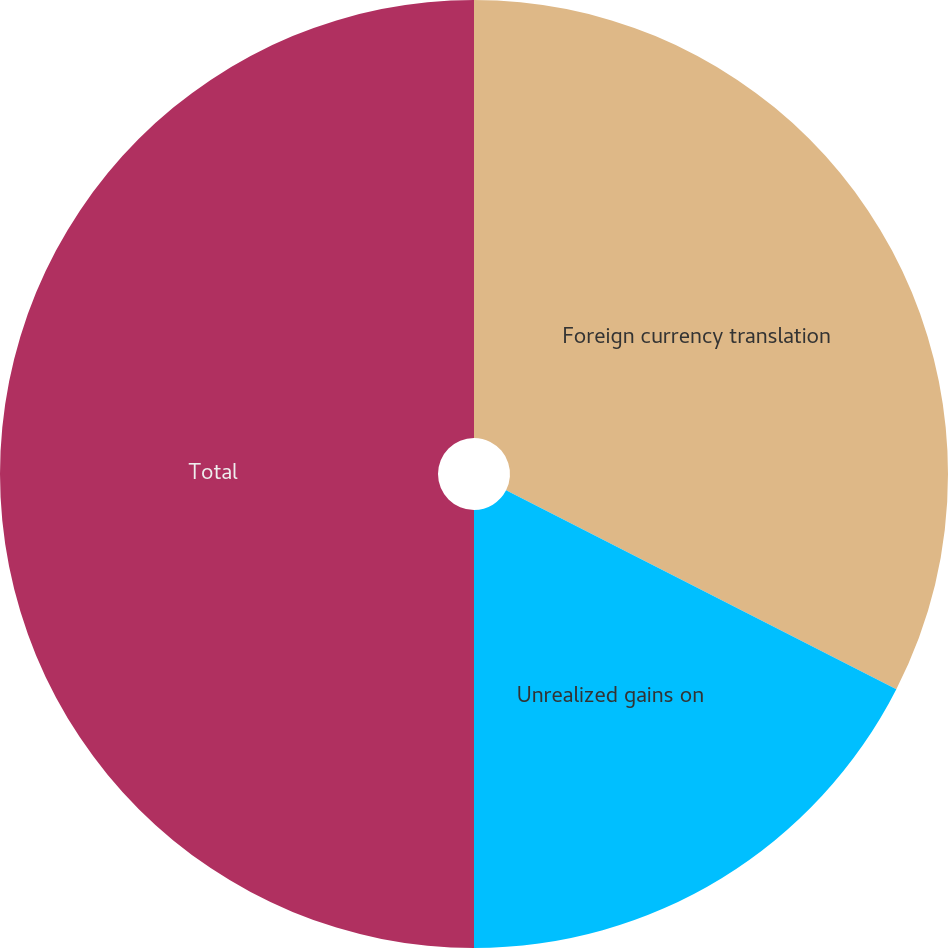<chart> <loc_0><loc_0><loc_500><loc_500><pie_chart><fcel>Foreign currency translation<fcel>Unrealized gains on<fcel>Total<nl><fcel>32.5%<fcel>17.5%<fcel>50.0%<nl></chart> 